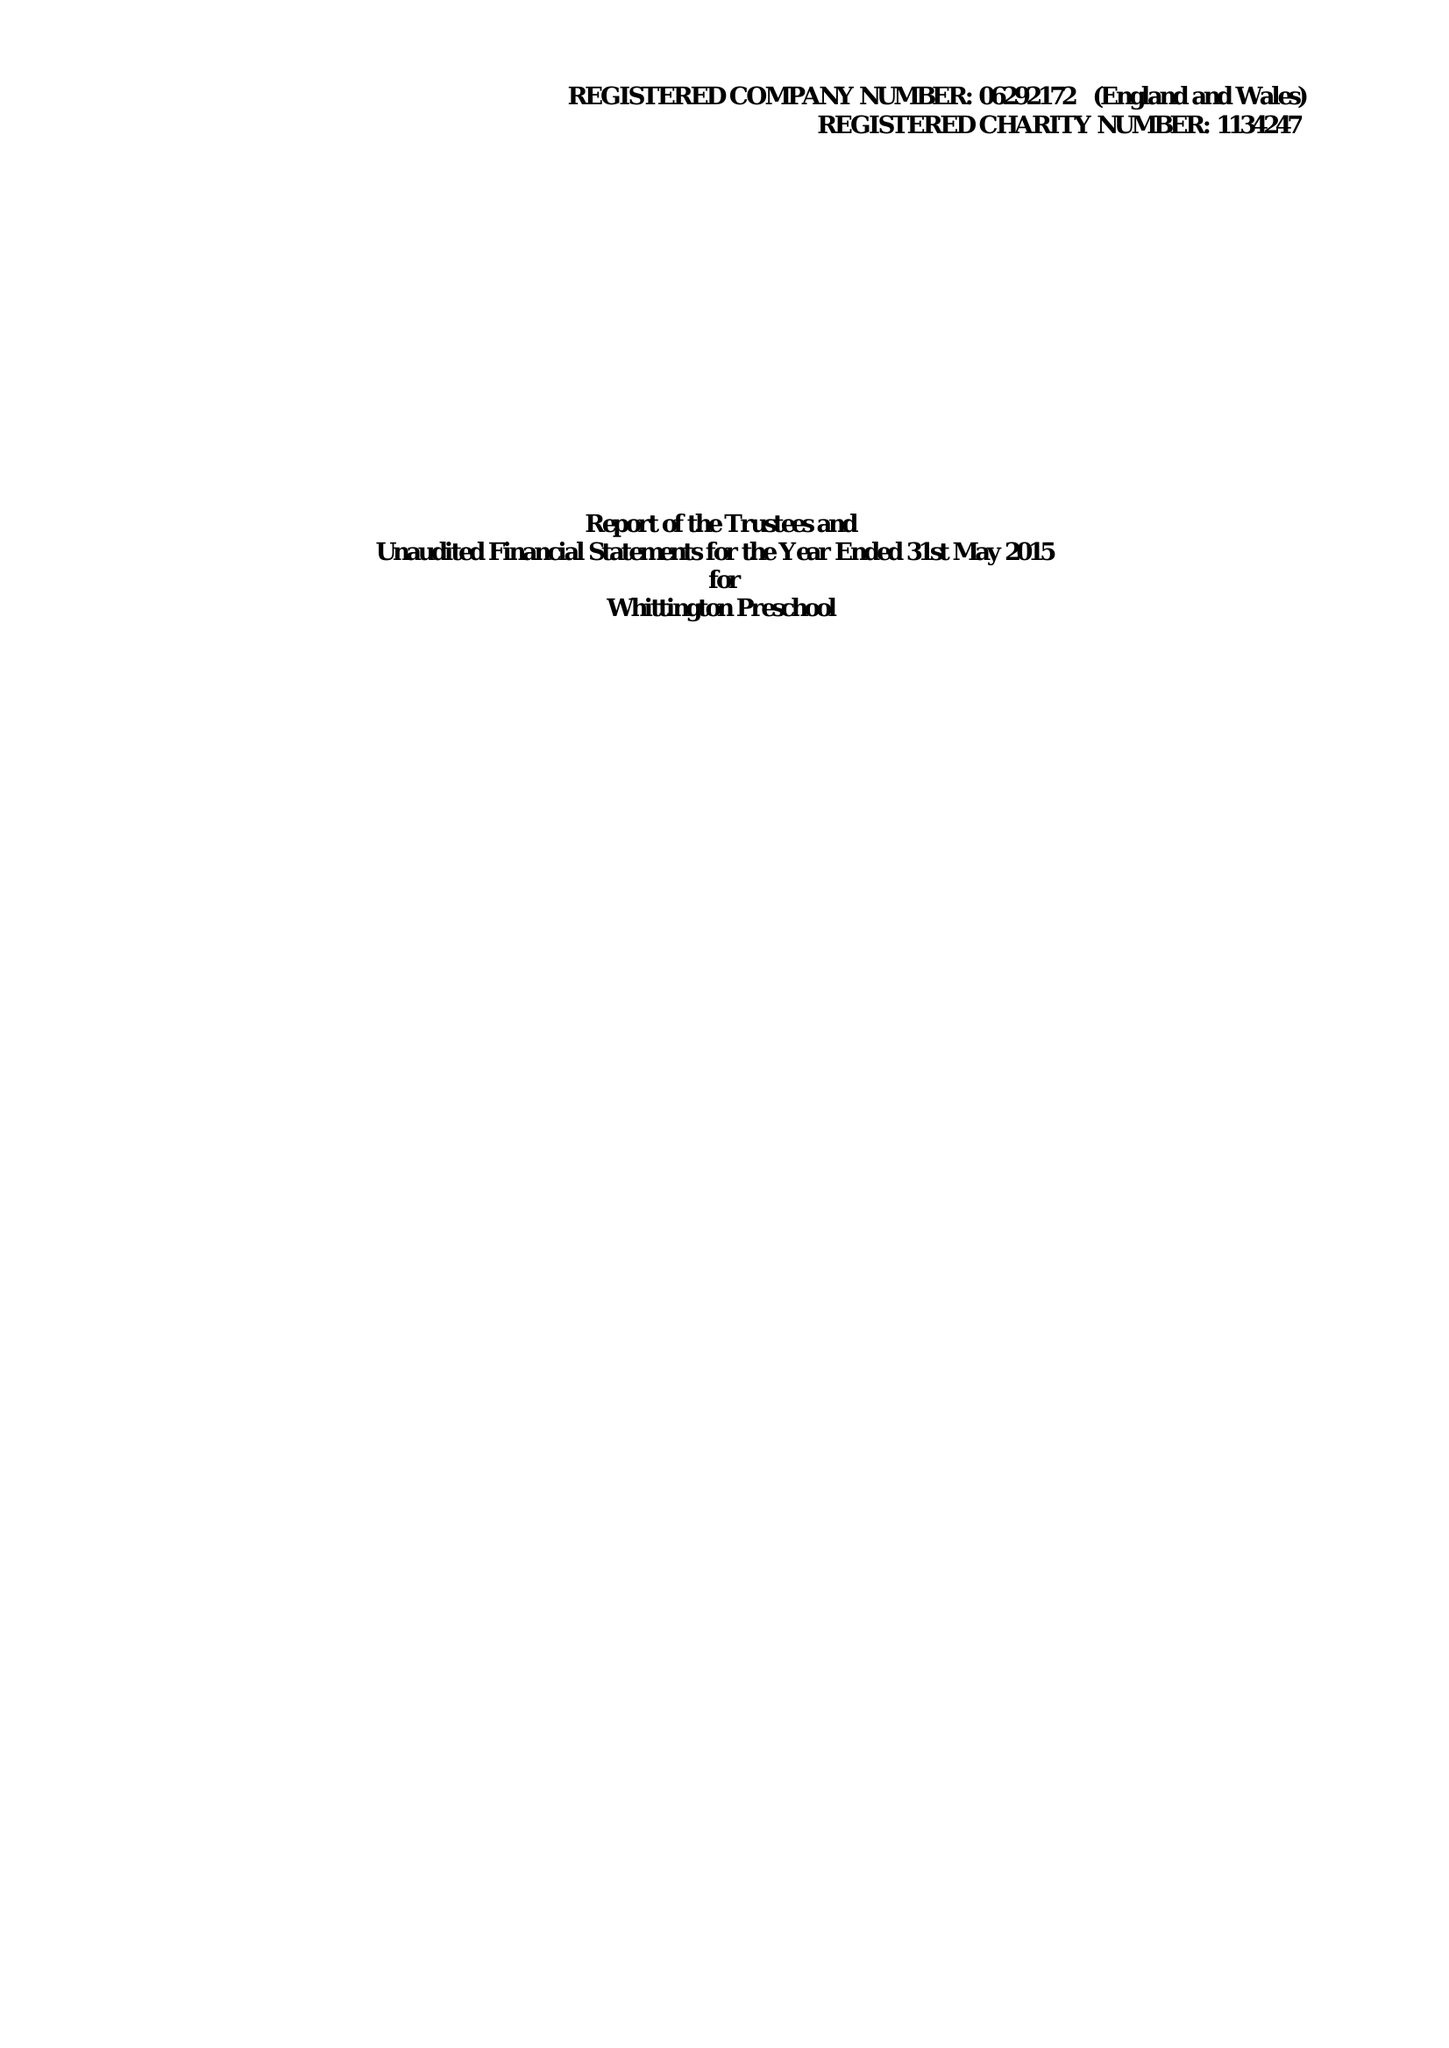What is the value for the charity_number?
Answer the question using a single word or phrase. 1134247 